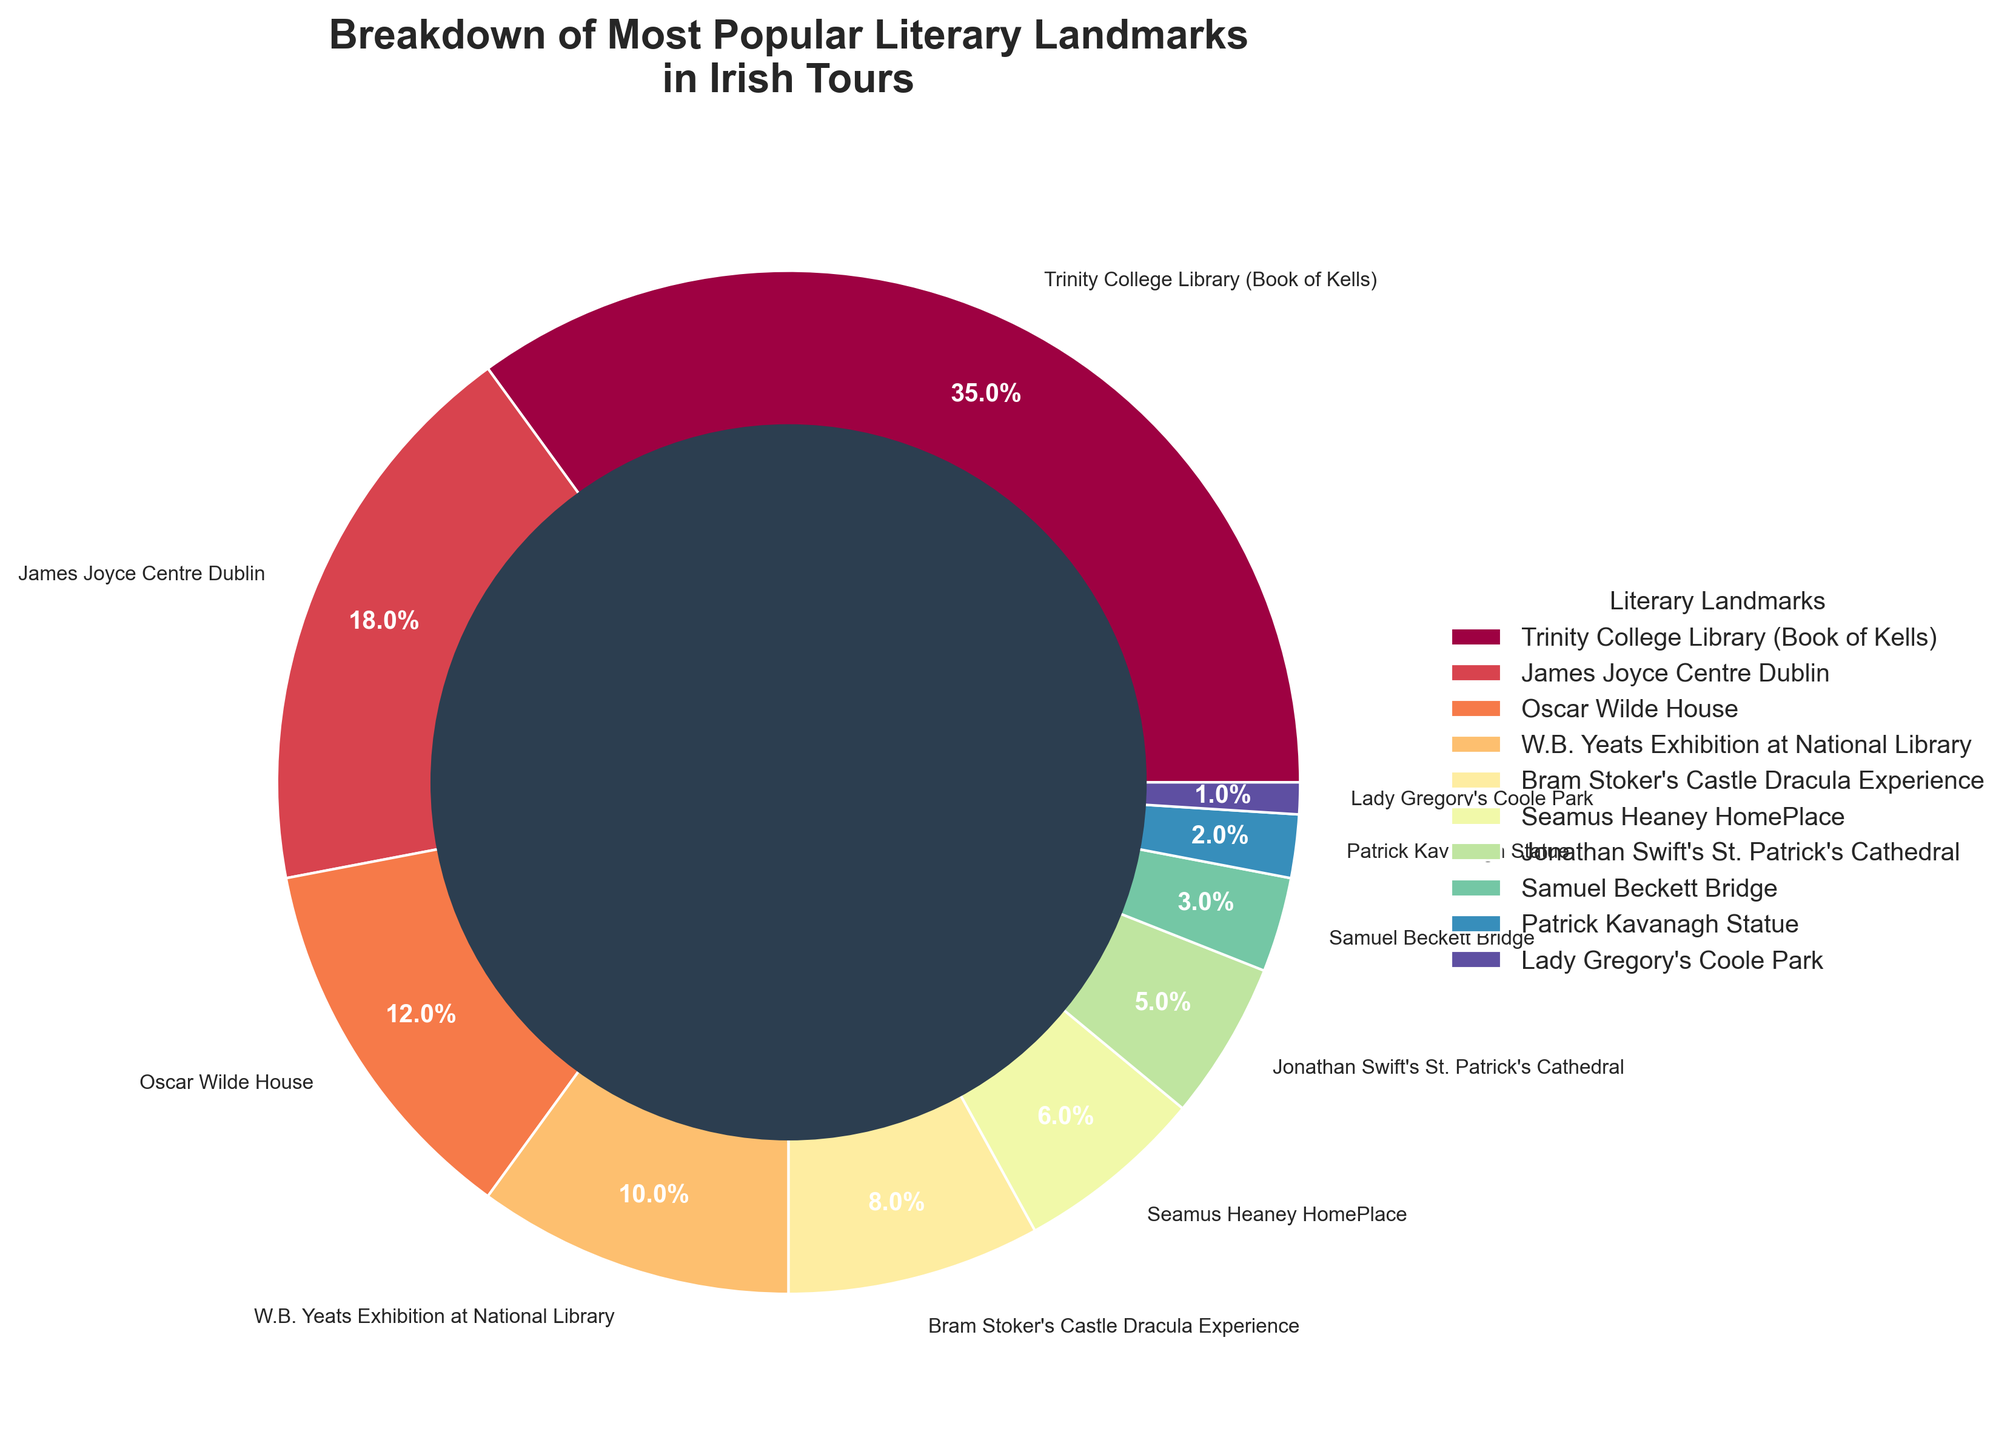What percentage of total visitors went to Trinity College Library (Book of Kells)? The pie chart shows that Trinity College Library (Book of Kells) has the largest section. The percentage noted in the slice for this landmark is 35%.
Answer: 35% Between James Joyce Centre Dublin and Oscar Wilde House, which had more visitors and by how much? James Joyce Centre Dublin received 18% of the visitors whereas Oscar Wilde House received 12%. The difference is 18% - 12% = 6%.
Answer: James Joyce Centre Dublin by 6% What is the combined percentage of visitors to Seamus Heaney HomePlace and Jonathan Swift's St. Patrick's Cathedral? Looking at the sections for Seamus Heaney HomePlace (6%) and Jonathan Swift's St. Patrick's Cathedral (5%), the combined percentage is 6% + 5% = 11%.
Answer: 11% If you sum the percentages of visitors who went to Bram Stoker's Castle Dracula Experience, Samuel Beckett Bridge, Patrick Kavanagh Statue, and Lady Gregory's Coole Park, what do you get? The percentages are Bram Stoker's Castle Dracula Experience (8%), Samuel Beckett Bridge (3%), Patrick Kavanagh Statue (2%), and Lady Gregory's Coole Park (1%). Their sum is 8% + 3% + 2% + 1% = 14%.
Answer: 14% Which landmarks received less than 10% of visitors and what are their combined percentages? The landmarks that received less than 10% of visitors are Bram Stoker's Castle Dracula Experience (8%), Seamus Heaney HomePlace (6%), Jonathan Swift's St. Patrick's Cathedral (5%), Samuel Beckett Bridge (3%), Patrick Kavanagh Statue (2%), and Lady Gregory's Coole Park (1%). The combined total is 8% + 6% + 5% + 3% + 2% + 1% = 25%.
Answer: Six landmarks, 25% Based on the data, how many landmarks received more than 10% of the visitors? The landmarks that received more than 10% of the visitors are Trinity College Library (Book of Kells) with 35%, James Joyce Centre Dublin with 18%, Oscar Wilde House with 12%, and W.B. Yeats Exhibition at National Library with 10%.
Answer: Four landmarks What's the average percentage of visitors for the top three most popular landmarks? The top three most popular landmarks are Trinity College Library (Book of Kells) with 35%, James Joyce Centre Dublin with 18%, and Oscar Wilde House with 12%. Their average percentage is (35% + 18% + 12%) / 3 = 21.67%.
Answer: 21.67% 